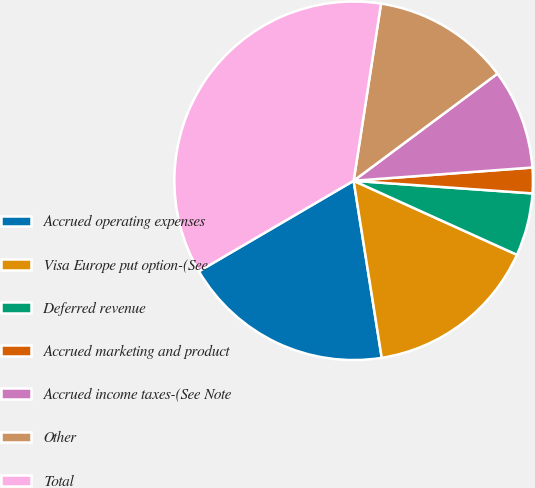Convert chart. <chart><loc_0><loc_0><loc_500><loc_500><pie_chart><fcel>Accrued operating expenses<fcel>Visa Europe put option-(See<fcel>Deferred revenue<fcel>Accrued marketing and product<fcel>Accrued income taxes-(See Note<fcel>Other<fcel>Total<nl><fcel>19.08%<fcel>15.72%<fcel>5.65%<fcel>2.3%<fcel>9.01%<fcel>12.37%<fcel>35.86%<nl></chart> 